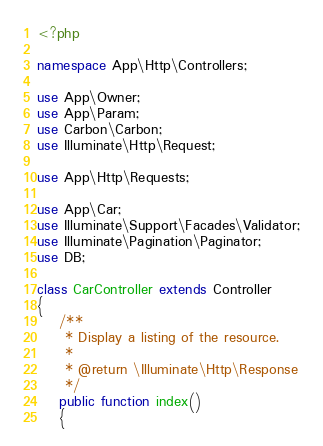Convert code to text. <code><loc_0><loc_0><loc_500><loc_500><_PHP_><?php

namespace App\Http\Controllers;

use App\Owner;
use App\Param;
use Carbon\Carbon;
use Illuminate\Http\Request;

use App\Http\Requests;

use App\Car;
use Illuminate\Support\Facades\Validator;
use Illuminate\Pagination\Paginator;
use DB;

class CarController extends Controller
{
    /**
     * Display a listing of the resource.
     *
     * @return \Illuminate\Http\Response
     */
    public function index()
    {</code> 